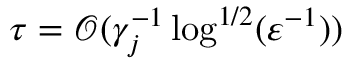<formula> <loc_0><loc_0><loc_500><loc_500>\tau = { \mathcal { O } } ( \gamma _ { j } ^ { - 1 } \log ^ { 1 / 2 } ( \varepsilon ^ { - 1 } ) )</formula> 